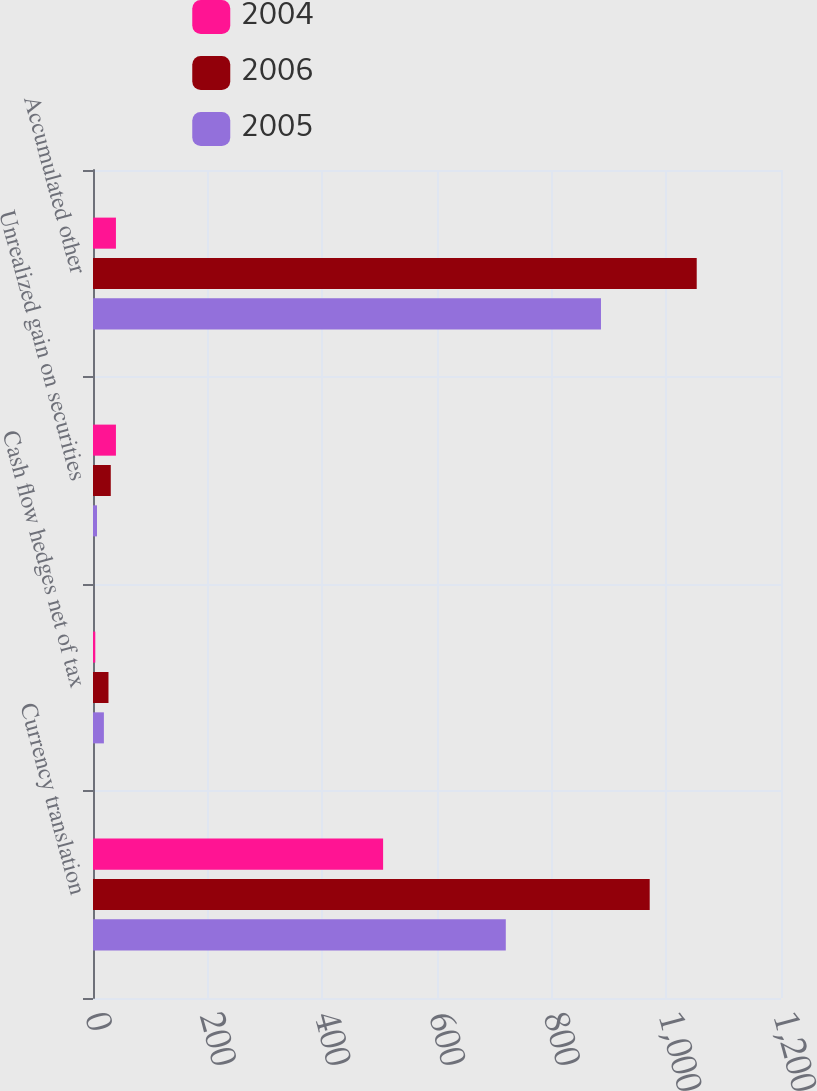Convert chart. <chart><loc_0><loc_0><loc_500><loc_500><stacked_bar_chart><ecel><fcel>Currency translation<fcel>Cash flow hedges net of tax<fcel>Unrealized gain on securities<fcel>Accumulated other<nl><fcel>2004<fcel>506<fcel>4<fcel>40<fcel>40<nl><fcel>2006<fcel>971<fcel>27<fcel>31<fcel>1053<nl><fcel>2005<fcel>720<fcel>19<fcel>7<fcel>886<nl></chart> 